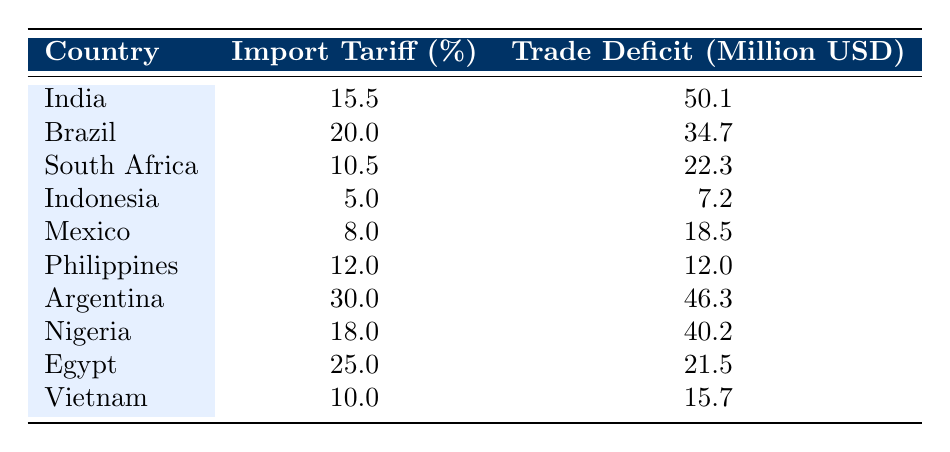What is the import tariff percentage for Argentina? In the table, the row for Argentina shows the import tariff percentage as 30.0.
Answer: 30.0 What is the trade deficit in million USD for South Africa? Looking at the row for South Africa, the trade deficit is listed as 22.3 million USD.
Answer: 22.3 Which country has the highest trade deficit? By examining the trade deficit values, India has the highest at 50.1 million USD compared to other countries.
Answer: India What is the average import tariff percentage across all countries listed? To find the average, sum the import tariff percentages (15.5 + 20.0 + 10.5 + 5.0 + 8.0 + 12.0 + 30.0 + 18.0 + 25.0 + 10.0 =  5.0)/10 = 12.8.
Answer: 12.8 Is it true that Nigeria has a lower import tariff than Argentina? Nigeria has an import tariff of 18.0, while Argentina's is 30.0; therefore, the statement is true.
Answer: Yes Which country has the lowest trade deficit, and what is the value? Upon reviewing the trade deficit values, Indonesia records the lowest trade deficit at 7.2 million USD.
Answer: Indonesia, 7.2 What is the total trade deficit for all countries combined? To calculate the total trade deficit, sum each country's trade deficit values: (50.1 + 34.7 + 22.3 + 7.2 + 18.5 + 12.0 + 46.3 + 40.2 + 21.5 + 15.7 =  278.1).
Answer: 278.1 Is Brazil's import tariff percentage greater than Egypt's? Brazil’s import tariff is 20.0, while Egypt’s is 25.0; thus, this statement is false.
Answer: No What is the difference in trade deficit between India and Mexico? The trade deficit for India is 50.1 and for Mexico it is 18.5; calculating the difference gives us (50.1 - 18.5 = 31.6).
Answer: 31.6 